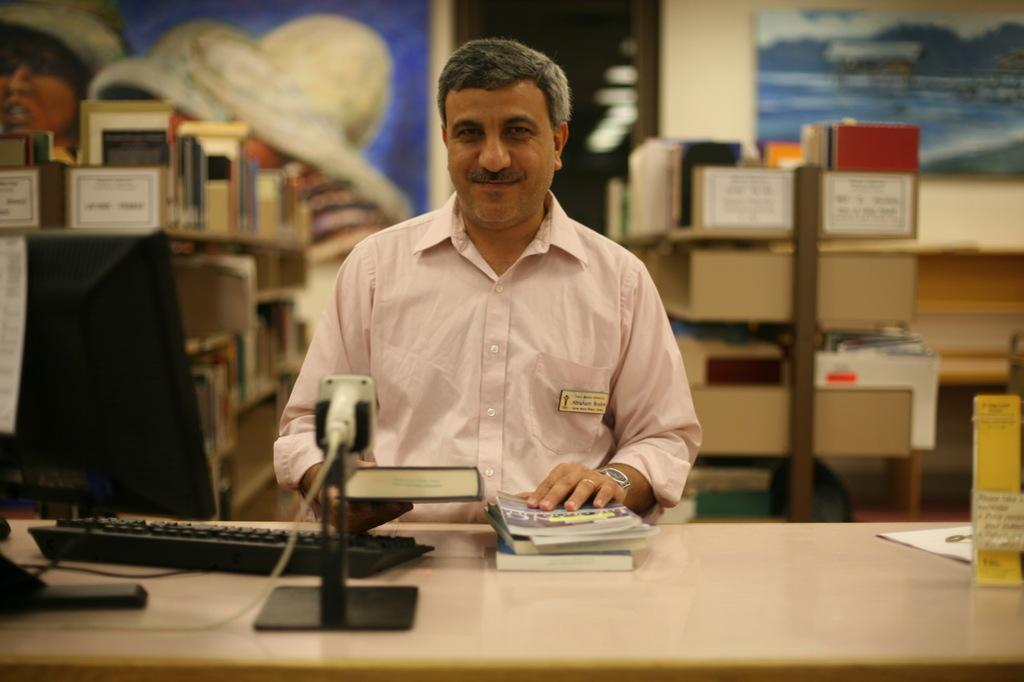Who is present in the image? There is a man in the picture. What is the man using in the image? The man is using a keyboard and a monitor, which are on the table. What else can be seen on the table? There are books on the table. What is visible in the background of the picture? There is a wall and a frame in the background of the picture. Is there any storage or shelving visible in the image? Yes, there is a rack in the picture. What type of hope can be seen in the image? There is no hope present in the image; it features a man using a keyboard, monitor, and books on a table. What kind of net is visible in the image? There is no net present in the image. 